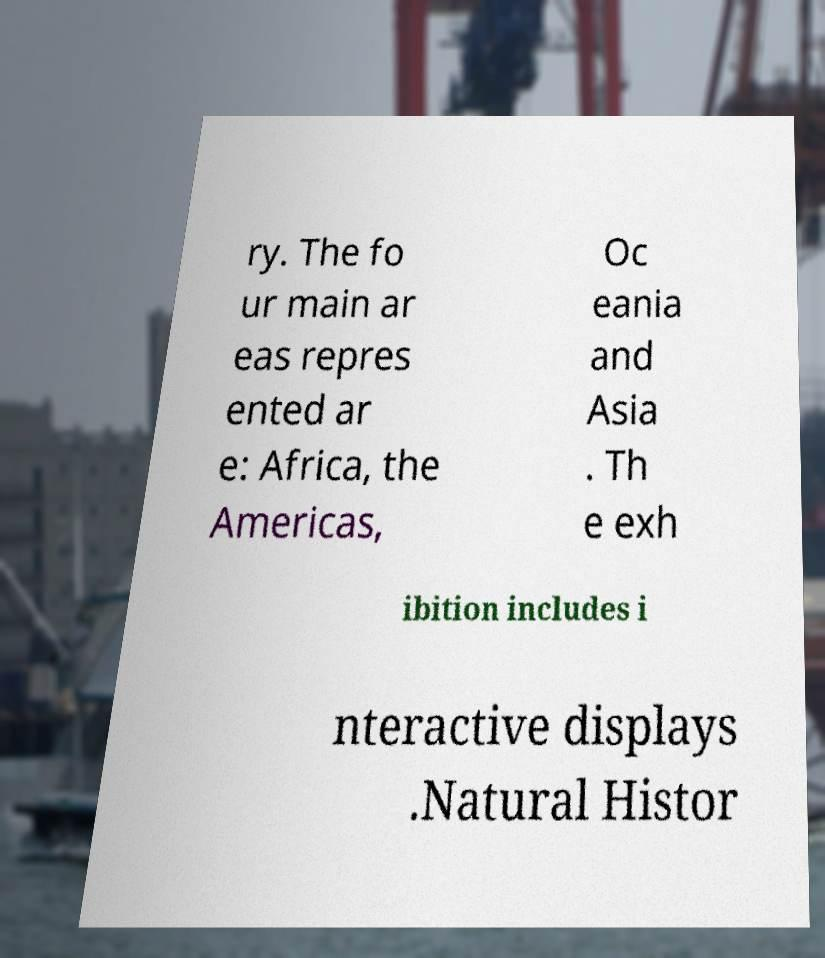Can you accurately transcribe the text from the provided image for me? ry. The fo ur main ar eas repres ented ar e: Africa, the Americas, Oc eania and Asia . Th e exh ibition includes i nteractive displays .Natural Histor 